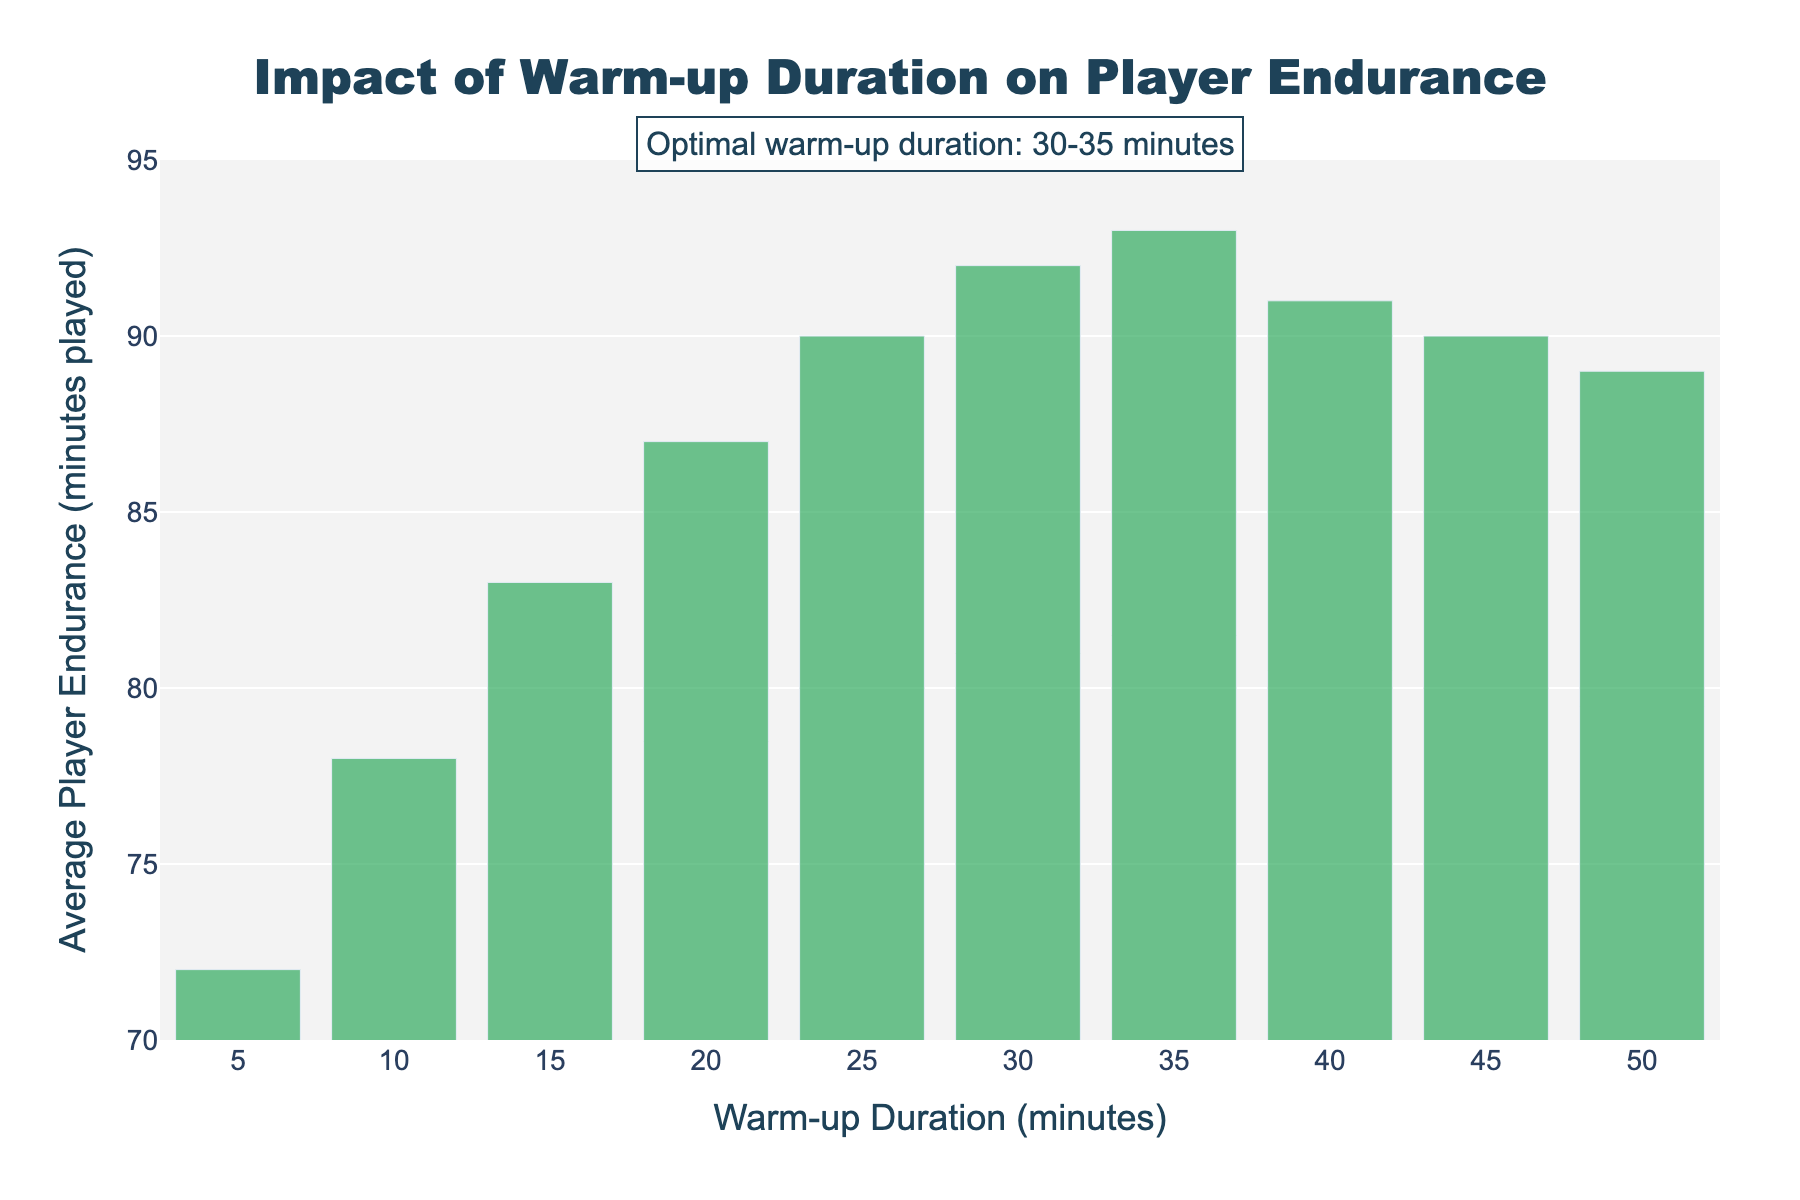Which warm-up duration corresponds to the highest average player endurance? From the bar chart, the highest average player endurance is seen at a warm-up duration of 35 minutes, with an endurance level of 93 minutes played.
Answer: 35 minutes How does the average player endurance change from a 5-minute to a 25-minute warm-up duration? At a 5-minute warm-up, average player endurance is 72 minutes, and at a 25-minute warm-up, it is 90 minutes. The change in endurance is 90 - 72 = 18 minutes.
Answer: 18 minutes What is the difference in average player endurance between the warm-up durations of 15 and 40 minutes? For 15 minutes of warm-up, the endurance is 83 minutes, and for 40 minutes, it is 91 minutes. The difference is 91 - 83 = 8 minutes.
Answer: 8 minutes Is there a trend in the average player endurance as the warm-up duration increases from 5 to 35 minutes? Endurance generally increases with a longer warm-up duration, peaking at 93 minutes when the warm-up is 35 minutes, suggesting that there is a positive correlation up to a certain point.
Answer: Yes, a positive trend What range of warm-up duration appears to be optimal for player endurance according to the annotation? The annotation on the chart indicates that the optimal warm-up duration is between 30 and 35 minutes.
Answer: 30-35 minutes How much does the average endurance drop when the warm-up duration increases from 35 to 45 minutes? At 35 minutes, endurance is 93 minutes, and at 45 minutes, it drops to 90 minutes. The drop in endurance is 93 - 90 = 3 minutes.
Answer: 3 minutes Which warm-up durations lead to an average player endurance of 90 minutes? From the bar chart, both 25 and 45 minutes of warm-up lead to an average player endurance of 90 minutes.
Answer: 25 and 45 minutes What is the average player endurance for warm-up durations greater than 30 minutes but less than or equal to 50 minutes? The endurance values for 35, 40, 45, and 50 minutes are 93, 91, 90, and 89 minutes respectively. The average is (93 + 91 + 90 + 89)/4 = 90.75 minutes.
Answer: 90.75 minutes Does a warm-up duration of 50 minutes provide higher endurance than a 20-minute warm-up? A 50-minute warm-up results in an endurance of 89 minutes, whereas a 20-minute warm-up results in an endurance of 87 minutes. Therefore, the 50-minute warm-up provides higher endurance.
Answer: Yes 